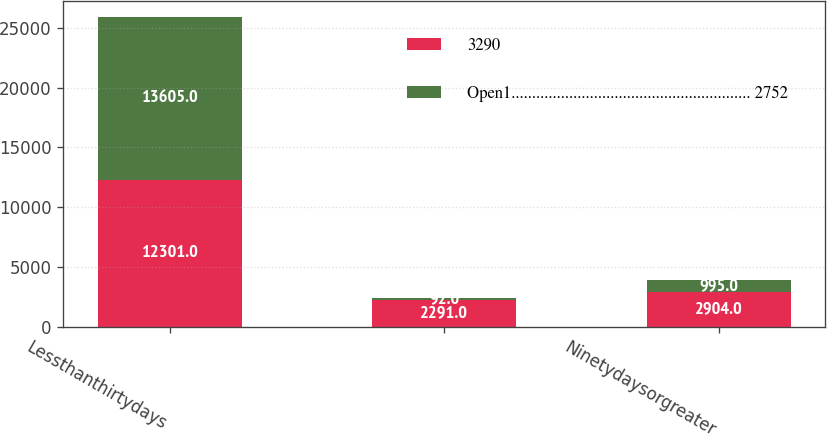<chart> <loc_0><loc_0><loc_500><loc_500><stacked_bar_chart><ecel><fcel>Lessthanthirtydays<fcel>Unnamed: 2<fcel>Ninetydaysorgreater<nl><fcel>3290<fcel>12301<fcel>2291<fcel>2904<nl><fcel>Open1.......................................................... 2752<fcel>13605<fcel>92<fcel>995<nl></chart> 